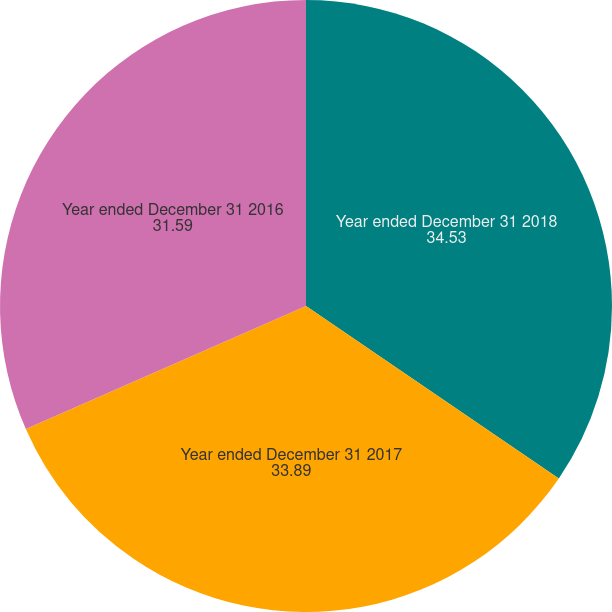Convert chart to OTSL. <chart><loc_0><loc_0><loc_500><loc_500><pie_chart><fcel>Year ended December 31 2018<fcel>Year ended December 31 2017<fcel>Year ended December 31 2016<nl><fcel>34.53%<fcel>33.89%<fcel>31.59%<nl></chart> 